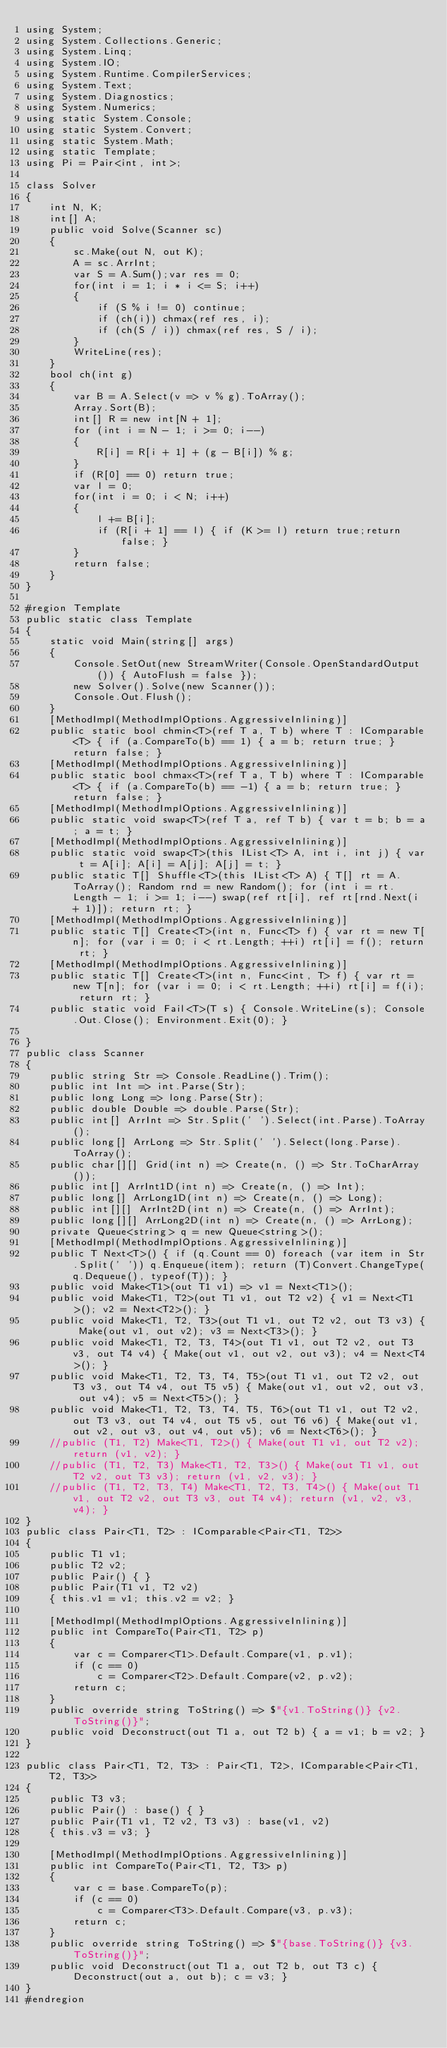<code> <loc_0><loc_0><loc_500><loc_500><_C#_>using System;
using System.Collections.Generic;
using System.Linq;
using System.IO;
using System.Runtime.CompilerServices;
using System.Text;
using System.Diagnostics;
using System.Numerics;
using static System.Console;
using static System.Convert;
using static System.Math;
using static Template;
using Pi = Pair<int, int>;

class Solver
{
    int N, K;
    int[] A;
    public void Solve(Scanner sc)
    {
        sc.Make(out N, out K);
        A = sc.ArrInt;
        var S = A.Sum();var res = 0;
        for(int i = 1; i * i <= S; i++)
        {
            if (S % i != 0) continue;
            if (ch(i)) chmax(ref res, i);
            if (ch(S / i)) chmax(ref res, S / i);
        }
        WriteLine(res);
    }
    bool ch(int g)
    {
        var B = A.Select(v => v % g).ToArray();
        Array.Sort(B);
        int[] R = new int[N + 1];
        for (int i = N - 1; i >= 0; i--)
        {
            R[i] = R[i + 1] + (g - B[i]) % g;
        }
        if (R[0] == 0) return true;
        var l = 0;
        for(int i = 0; i < N; i++)
        {
            l += B[i];
            if (R[i + 1] == l) { if (K >= l) return true;return false; }
        }
        return false;
    }
}

#region Template
public static class Template
{
    static void Main(string[] args)
    {
        Console.SetOut(new StreamWriter(Console.OpenStandardOutput()) { AutoFlush = false });
        new Solver().Solve(new Scanner());
        Console.Out.Flush();
    }
    [MethodImpl(MethodImplOptions.AggressiveInlining)]
    public static bool chmin<T>(ref T a, T b) where T : IComparable<T> { if (a.CompareTo(b) == 1) { a = b; return true; } return false; }
    [MethodImpl(MethodImplOptions.AggressiveInlining)]
    public static bool chmax<T>(ref T a, T b) where T : IComparable<T> { if (a.CompareTo(b) == -1) { a = b; return true; } return false; }
    [MethodImpl(MethodImplOptions.AggressiveInlining)]
    public static void swap<T>(ref T a, ref T b) { var t = b; b = a; a = t; }
    [MethodImpl(MethodImplOptions.AggressiveInlining)]
    public static void swap<T>(this IList<T> A, int i, int j) { var t = A[i]; A[i] = A[j]; A[j] = t; }
    public static T[] Shuffle<T>(this IList<T> A) { T[] rt = A.ToArray(); Random rnd = new Random(); for (int i = rt.Length - 1; i >= 1; i--) swap(ref rt[i], ref rt[rnd.Next(i + 1)]); return rt; }
    [MethodImpl(MethodImplOptions.AggressiveInlining)]
    public static T[] Create<T>(int n, Func<T> f) { var rt = new T[n]; for (var i = 0; i < rt.Length; ++i) rt[i] = f(); return rt; }
    [MethodImpl(MethodImplOptions.AggressiveInlining)]
    public static T[] Create<T>(int n, Func<int, T> f) { var rt = new T[n]; for (var i = 0; i < rt.Length; ++i) rt[i] = f(i); return rt; }
    public static void Fail<T>(T s) { Console.WriteLine(s); Console.Out.Close(); Environment.Exit(0); }

}
public class Scanner
{
    public string Str => Console.ReadLine().Trim();
    public int Int => int.Parse(Str);
    public long Long => long.Parse(Str);
    public double Double => double.Parse(Str);
    public int[] ArrInt => Str.Split(' ').Select(int.Parse).ToArray();
    public long[] ArrLong => Str.Split(' ').Select(long.Parse).ToArray();
    public char[][] Grid(int n) => Create(n, () => Str.ToCharArray());
    public int[] ArrInt1D(int n) => Create(n, () => Int);
    public long[] ArrLong1D(int n) => Create(n, () => Long);
    public int[][] ArrInt2D(int n) => Create(n, () => ArrInt);
    public long[][] ArrLong2D(int n) => Create(n, () => ArrLong);
    private Queue<string> q = new Queue<string>();
    [MethodImpl(MethodImplOptions.AggressiveInlining)]
    public T Next<T>() { if (q.Count == 0) foreach (var item in Str.Split(' ')) q.Enqueue(item); return (T)Convert.ChangeType(q.Dequeue(), typeof(T)); }
    public void Make<T1>(out T1 v1) => v1 = Next<T1>();
    public void Make<T1, T2>(out T1 v1, out T2 v2) { v1 = Next<T1>(); v2 = Next<T2>(); }
    public void Make<T1, T2, T3>(out T1 v1, out T2 v2, out T3 v3) { Make(out v1, out v2); v3 = Next<T3>(); }
    public void Make<T1, T2, T3, T4>(out T1 v1, out T2 v2, out T3 v3, out T4 v4) { Make(out v1, out v2, out v3); v4 = Next<T4>(); }
    public void Make<T1, T2, T3, T4, T5>(out T1 v1, out T2 v2, out T3 v3, out T4 v4, out T5 v5) { Make(out v1, out v2, out v3, out v4); v5 = Next<T5>(); }
    public void Make<T1, T2, T3, T4, T5, T6>(out T1 v1, out T2 v2, out T3 v3, out T4 v4, out T5 v5, out T6 v6) { Make(out v1, out v2, out v3, out v4, out v5); v6 = Next<T6>(); }
    //public (T1, T2) Make<T1, T2>() { Make(out T1 v1, out T2 v2); return (v1, v2); }
    //public (T1, T2, T3) Make<T1, T2, T3>() { Make(out T1 v1, out T2 v2, out T3 v3); return (v1, v2, v3); }
    //public (T1, T2, T3, T4) Make<T1, T2, T3, T4>() { Make(out T1 v1, out T2 v2, out T3 v3, out T4 v4); return (v1, v2, v3, v4); }
}
public class Pair<T1, T2> : IComparable<Pair<T1, T2>>
{
    public T1 v1;
    public T2 v2;
    public Pair() { }
    public Pair(T1 v1, T2 v2)
    { this.v1 = v1; this.v2 = v2; }

    [MethodImpl(MethodImplOptions.AggressiveInlining)]
    public int CompareTo(Pair<T1, T2> p)
    {
        var c = Comparer<T1>.Default.Compare(v1, p.v1);
        if (c == 0)
            c = Comparer<T2>.Default.Compare(v2, p.v2);
        return c;
    }
    public override string ToString() => $"{v1.ToString()} {v2.ToString()}";
    public void Deconstruct(out T1 a, out T2 b) { a = v1; b = v2; }
}

public class Pair<T1, T2, T3> : Pair<T1, T2>, IComparable<Pair<T1, T2, T3>>
{
    public T3 v3;
    public Pair() : base() { }
    public Pair(T1 v1, T2 v2, T3 v3) : base(v1, v2)
    { this.v3 = v3; }

    [MethodImpl(MethodImplOptions.AggressiveInlining)]
    public int CompareTo(Pair<T1, T2, T3> p)
    {
        var c = base.CompareTo(p);
        if (c == 0)
            c = Comparer<T3>.Default.Compare(v3, p.v3);
        return c;
    }
    public override string ToString() => $"{base.ToString()} {v3.ToString()}";
    public void Deconstruct(out T1 a, out T2 b, out T3 c) { Deconstruct(out a, out b); c = v3; }
}
#endregion</code> 